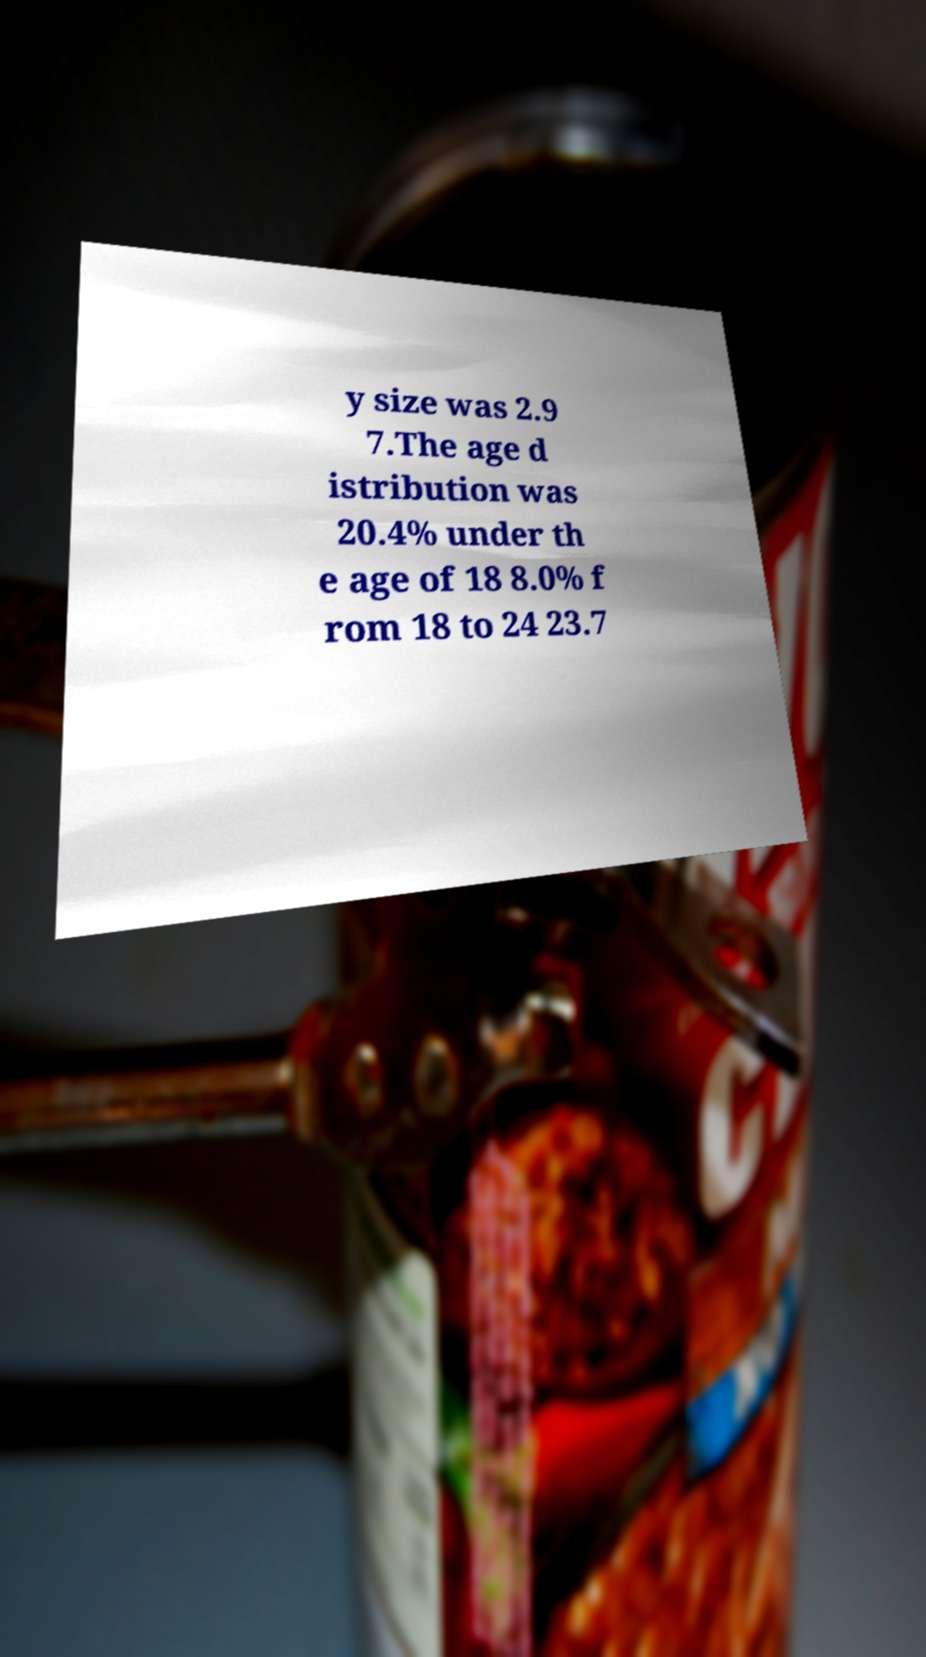Could you assist in decoding the text presented in this image and type it out clearly? y size was 2.9 7.The age d istribution was 20.4% under th e age of 18 8.0% f rom 18 to 24 23.7 